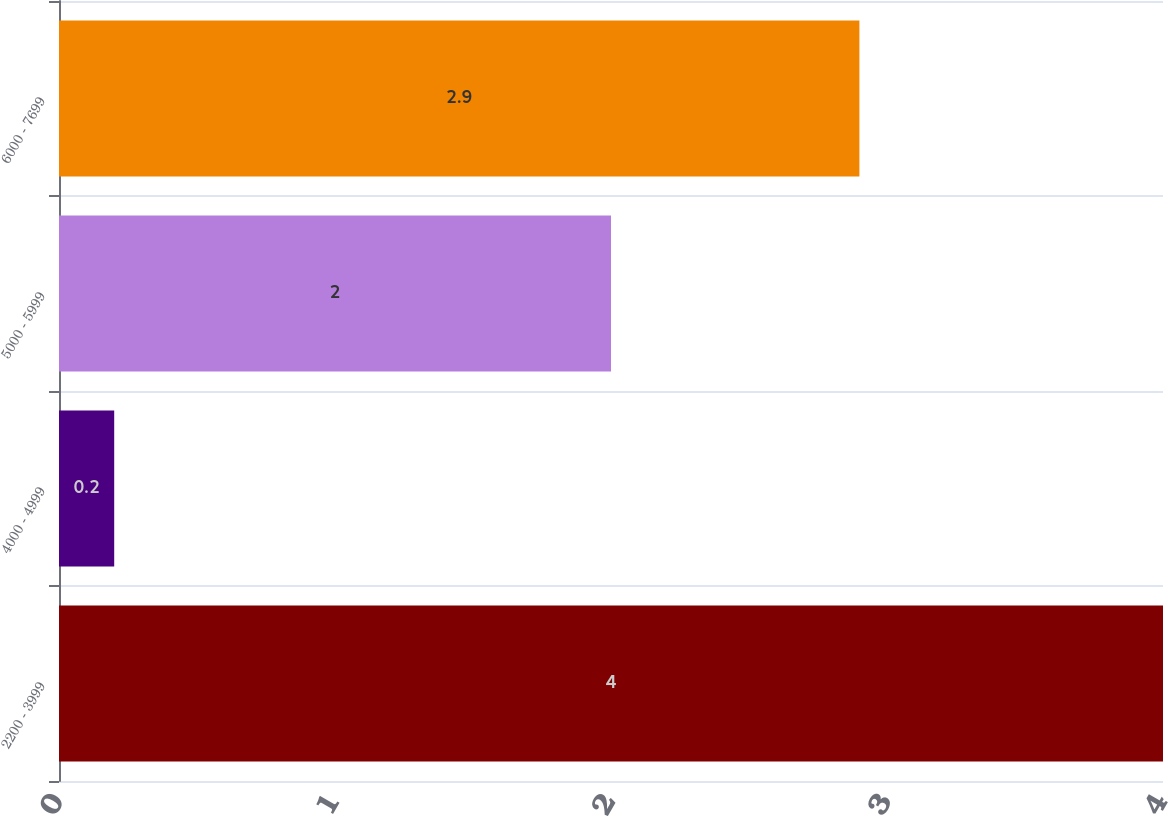<chart> <loc_0><loc_0><loc_500><loc_500><bar_chart><fcel>2200 - 3999<fcel>4000 - 4999<fcel>5000 - 5999<fcel>6000 - 7699<nl><fcel>4<fcel>0.2<fcel>2<fcel>2.9<nl></chart> 